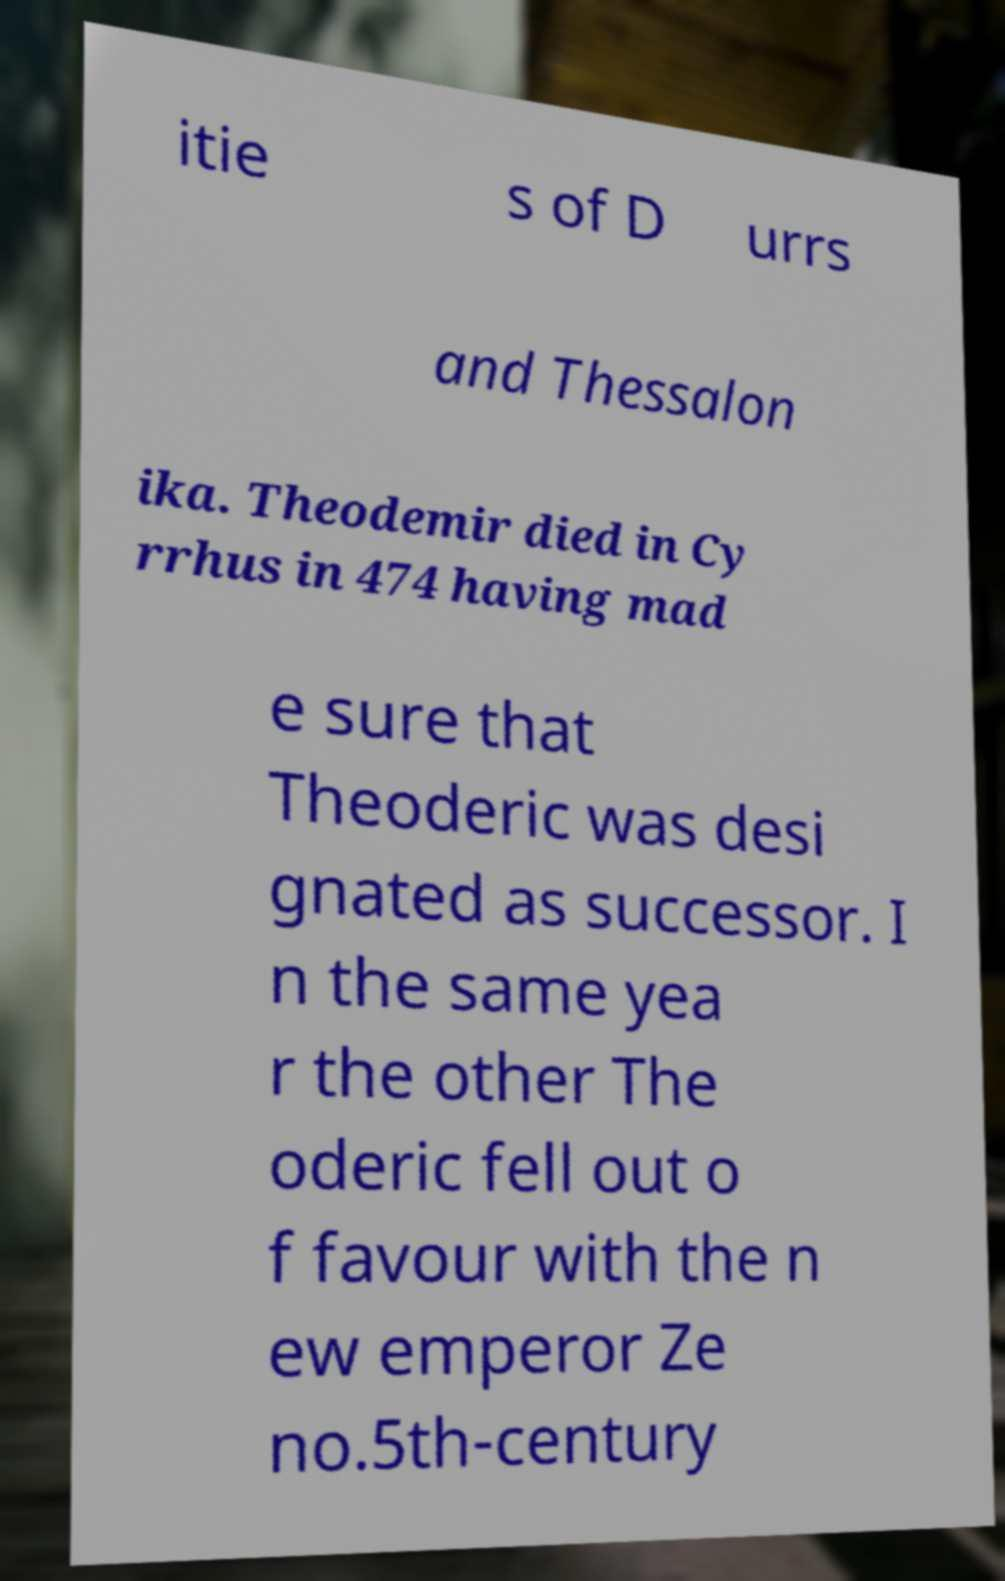Can you read and provide the text displayed in the image?This photo seems to have some interesting text. Can you extract and type it out for me? itie s of D urrs and Thessalon ika. Theodemir died in Cy rrhus in 474 having mad e sure that Theoderic was desi gnated as successor. I n the same yea r the other The oderic fell out o f favour with the n ew emperor Ze no.5th-century 